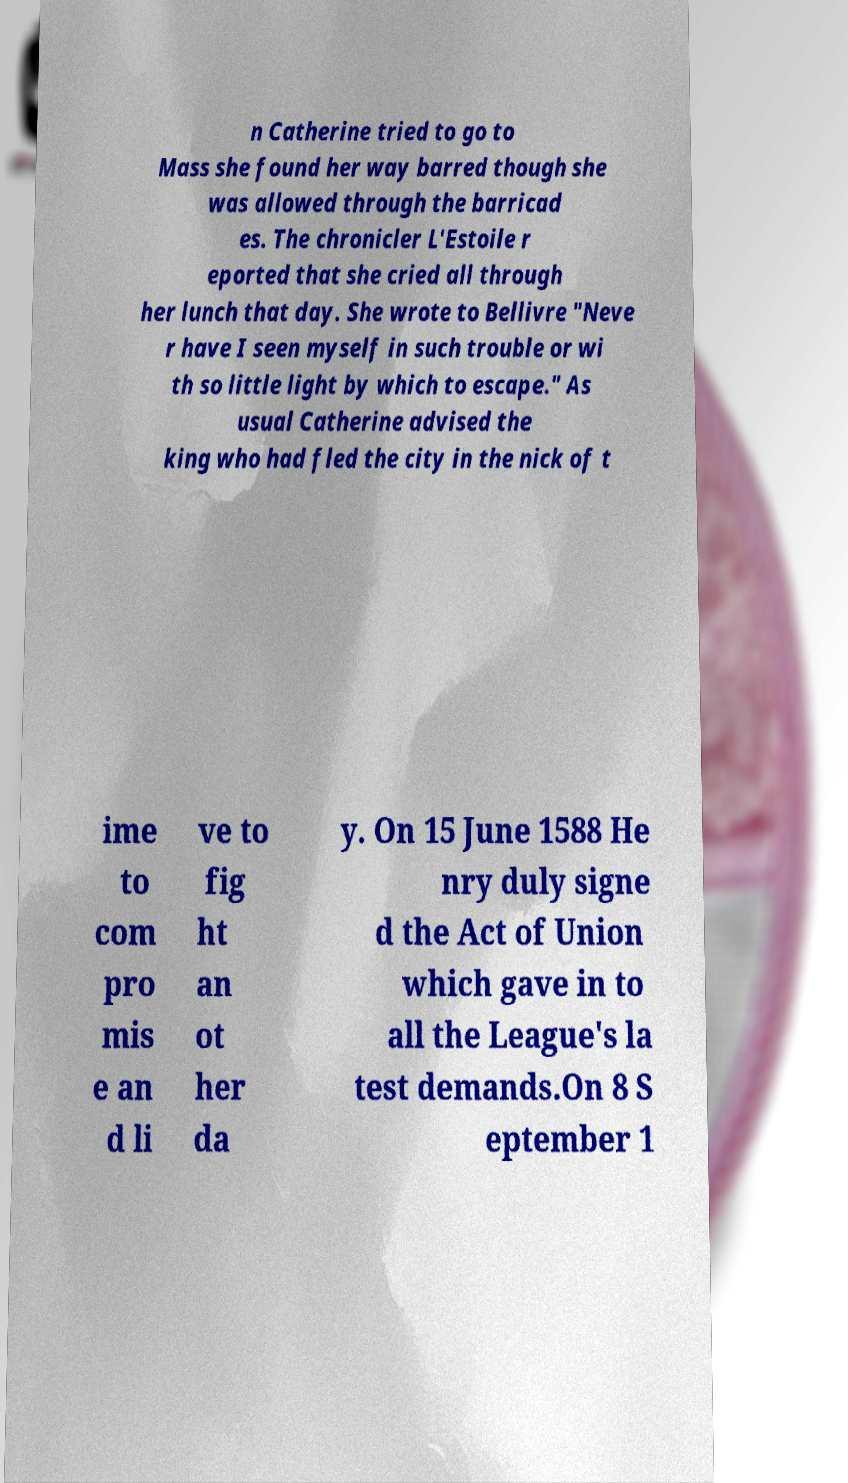Could you extract and type out the text from this image? n Catherine tried to go to Mass she found her way barred though she was allowed through the barricad es. The chronicler L'Estoile r eported that she cried all through her lunch that day. She wrote to Bellivre "Neve r have I seen myself in such trouble or wi th so little light by which to escape." As usual Catherine advised the king who had fled the city in the nick of t ime to com pro mis e an d li ve to fig ht an ot her da y. On 15 June 1588 He nry duly signe d the Act of Union which gave in to all the League's la test demands.On 8 S eptember 1 